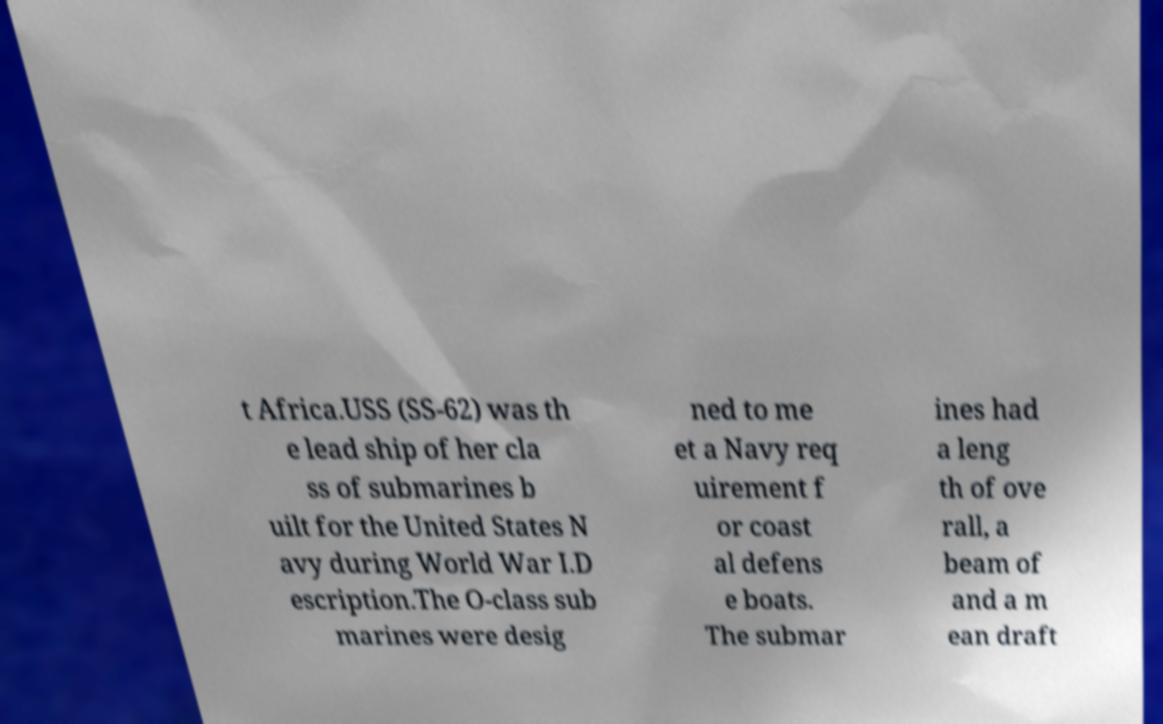What messages or text are displayed in this image? I need them in a readable, typed format. t Africa.USS (SS-62) was th e lead ship of her cla ss of submarines b uilt for the United States N avy during World War I.D escription.The O-class sub marines were desig ned to me et a Navy req uirement f or coast al defens e boats. The submar ines had a leng th of ove rall, a beam of and a m ean draft 